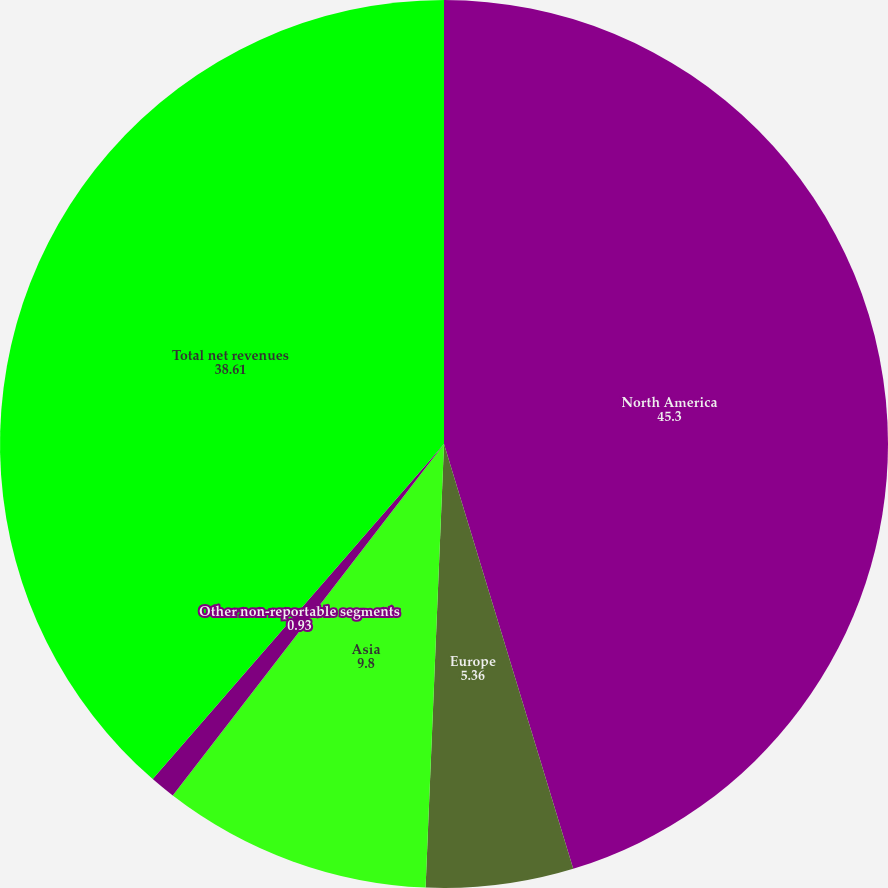Convert chart to OTSL. <chart><loc_0><loc_0><loc_500><loc_500><pie_chart><fcel>North America<fcel>Europe<fcel>Asia<fcel>Other non-reportable segments<fcel>Total net revenues<nl><fcel>45.3%<fcel>5.36%<fcel>9.8%<fcel>0.93%<fcel>38.61%<nl></chart> 